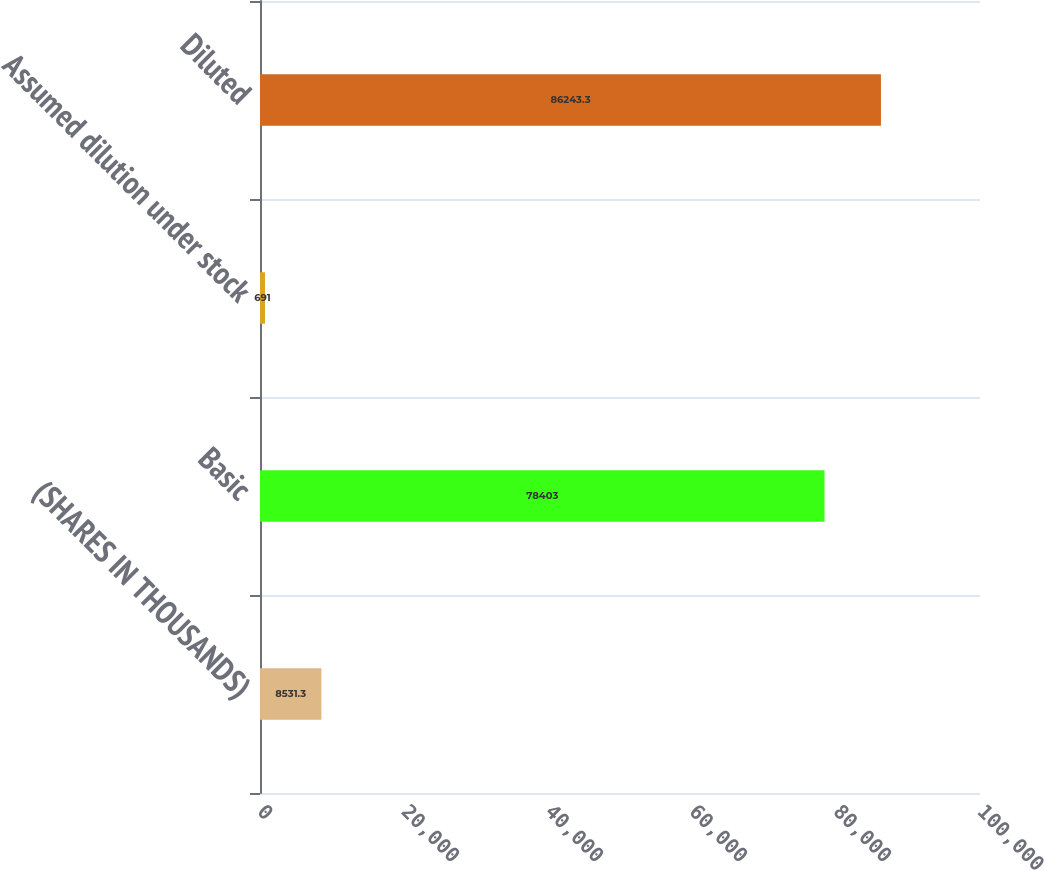Convert chart. <chart><loc_0><loc_0><loc_500><loc_500><bar_chart><fcel>(SHARES IN THOUSANDS)<fcel>Basic<fcel>Assumed dilution under stock<fcel>Diluted<nl><fcel>8531.3<fcel>78403<fcel>691<fcel>86243.3<nl></chart> 